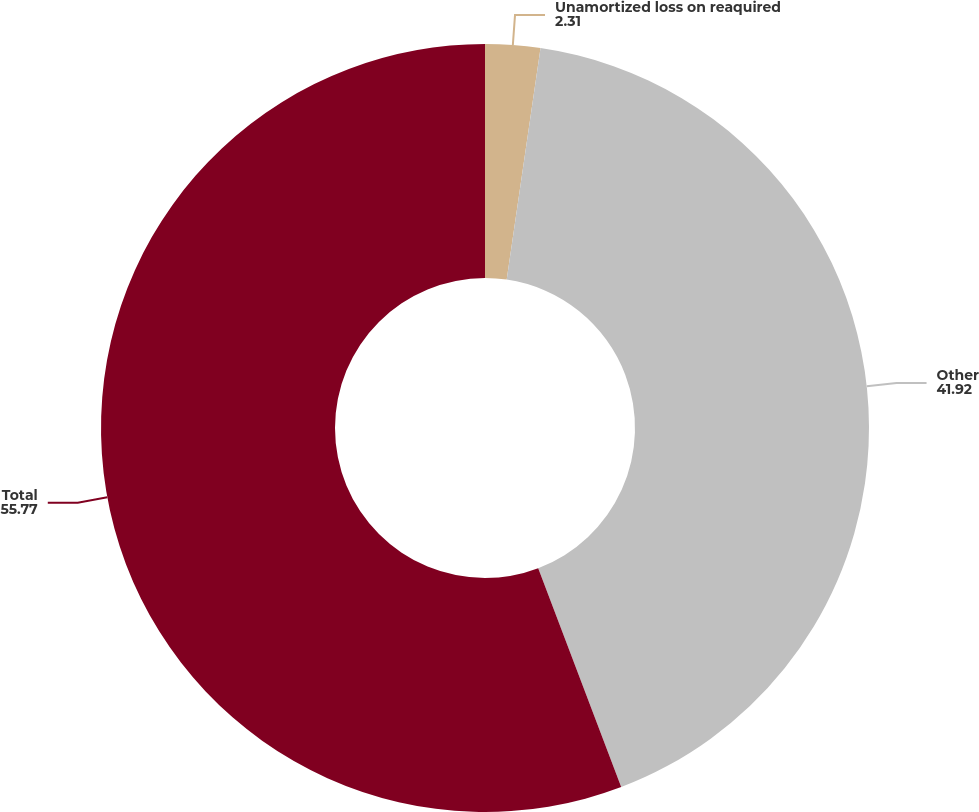Convert chart to OTSL. <chart><loc_0><loc_0><loc_500><loc_500><pie_chart><fcel>Unamortized loss on reaquired<fcel>Other<fcel>Total<nl><fcel>2.31%<fcel>41.92%<fcel>55.77%<nl></chart> 